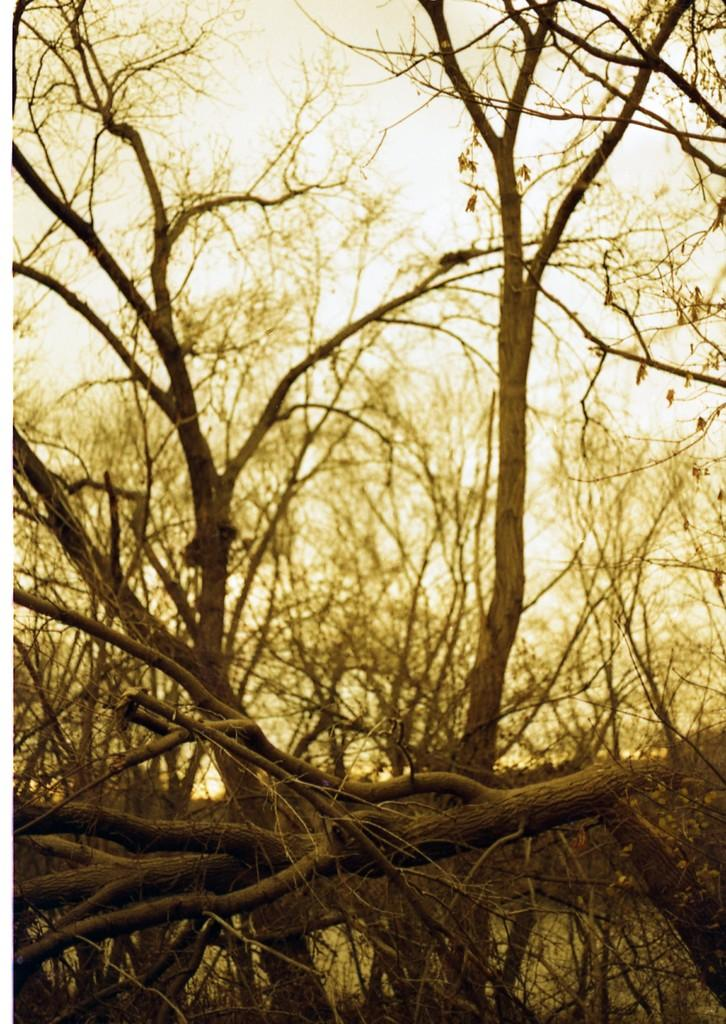Where was the image taken? The image was taken outdoors. What can be seen at the top of the image? The sky is visible at the top of the image. What is the main feature in the middle of the image? There are many trees in the middle of the image. Can you describe the trees in the image? The trees have stems and branches. What type of sugar is being used to tie a knot in the image? There is no sugar or knot present in the image. The image features trees with stems and branches. 